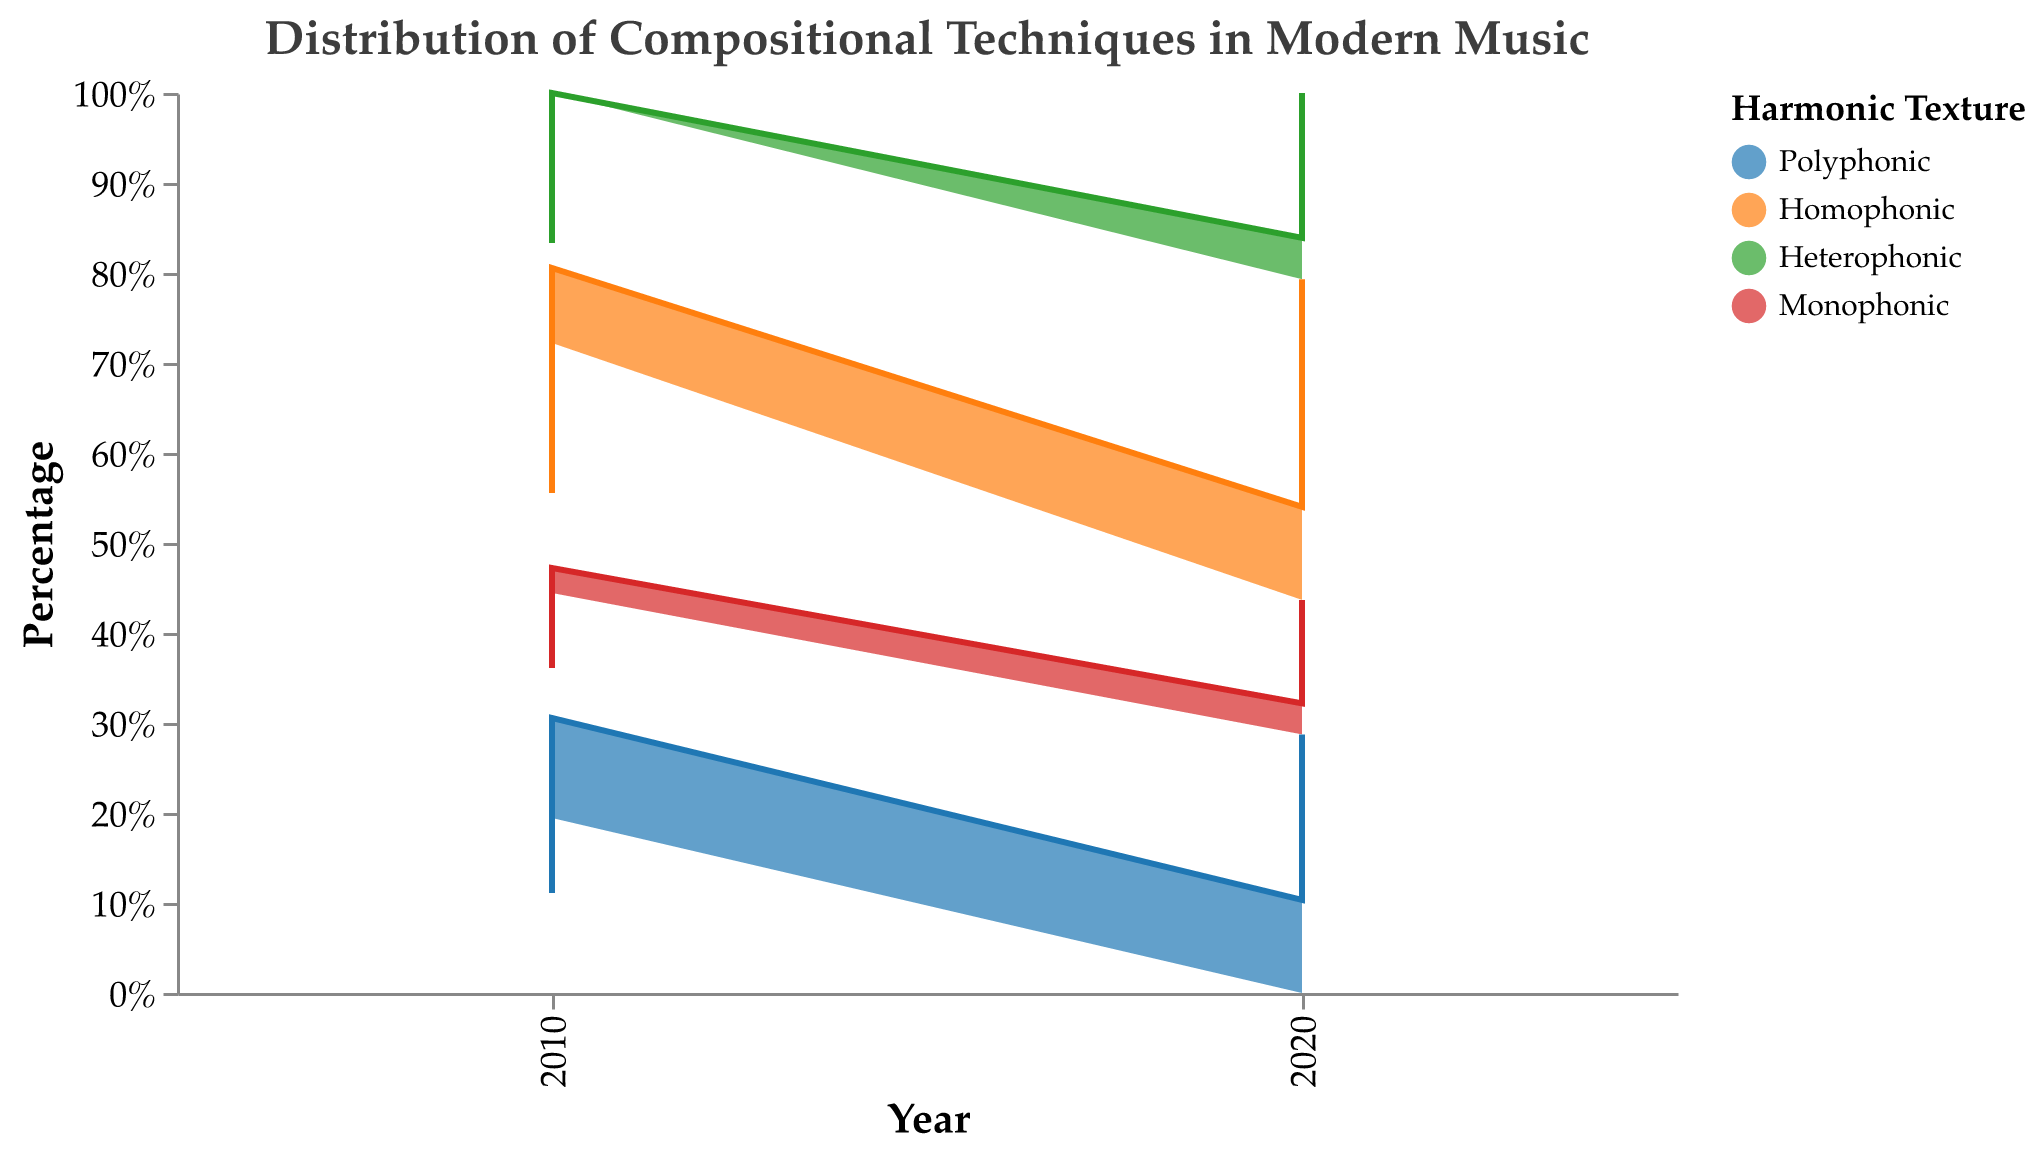What's the title of the chart? The title of the chart is located at the top of the figure.
Answer: "Distribution of Compositional Techniques in Modern Music" Which harmonic texture had the highest percentage for Serialism in 2020? Look for the Serialism compositional technique in 2020 and identify the harmonic texture with the highest percentage.
Answer: Homophonic What is the total percentage of Polyphonic texture for all techniques in 2010? Sum up the percentage values for Polyphonic texture across all compositional techniques in the year 2010: 20+10+5+20.
Answer: 55% Compare the percentage of Heterophonic texture in Minimalism from 2010 to 2020. Did it increase or decrease? Compare the values of Heterophonic texture for Minimalism in 2010 and 2020: 15 in 2010 and 14 in 2020.
Answer: Decrease What harmonic texture decreased the most for Post-Romanticism from 2010 to 2020? Compare the percentage values for each harmonic texture for Post-Romanticism between the years 2010 and 2020 and find the one with the most significant decrease. Heterophonic texture decreased from 0% to 4%
Answer: Monophonic Which compositional technique had the highest representation of Homophonic texture in 2020? Look for the highest percentage in Homophonic texture in 2020 across all compositional techniques and find the corresponding one.
Answer: Polystylism Did Polyphonic texture of Minimalism increase or decrease from 2010 to 2020? Compare the percentage values of Polyphonic texture for Minimalism in 2010 and 2020: 5 in 2010 and 8 in 2020.
Answer: Increase By how much did the percentage of Homophonic texture in Serialism change from 2010 to 2020? Calculate the change in Homophonic texture percentage for Serialism from 2010 to 2020: 18 - 15.
Answer: 3% Which harmonic texture in Polystylism showed no change from 2010 to 2020? Identify the harmonic texture in Polystylism whose percentage remained the same between 2010 and 2020.
Answer: Monophonic What is the dominant harmonic texture for the compositional techniques in 2010? Sum up the percentages of each harmonic texture across all techniques in 2010 and identify the one with the highest sum.
Answer: Polyphonic 